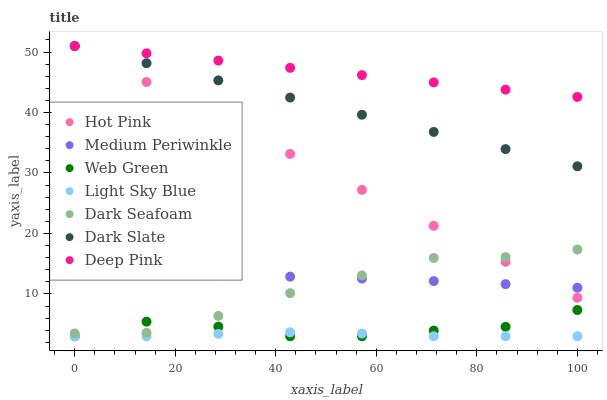Does Light Sky Blue have the minimum area under the curve?
Answer yes or no. Yes. Does Deep Pink have the maximum area under the curve?
Answer yes or no. Yes. Does Hot Pink have the minimum area under the curve?
Answer yes or no. No. Does Hot Pink have the maximum area under the curve?
Answer yes or no. No. Is Deep Pink the smoothest?
Answer yes or no. Yes. Is Web Green the roughest?
Answer yes or no. Yes. Is Hot Pink the smoothest?
Answer yes or no. No. Is Hot Pink the roughest?
Answer yes or no. No. Does Web Green have the lowest value?
Answer yes or no. Yes. Does Hot Pink have the lowest value?
Answer yes or no. No. Does Dark Slate have the highest value?
Answer yes or no. Yes. Does Medium Periwinkle have the highest value?
Answer yes or no. No. Is Light Sky Blue less than Hot Pink?
Answer yes or no. Yes. Is Dark Slate greater than Dark Seafoam?
Answer yes or no. Yes. Does Dark Seafoam intersect Hot Pink?
Answer yes or no. Yes. Is Dark Seafoam less than Hot Pink?
Answer yes or no. No. Is Dark Seafoam greater than Hot Pink?
Answer yes or no. No. Does Light Sky Blue intersect Hot Pink?
Answer yes or no. No. 